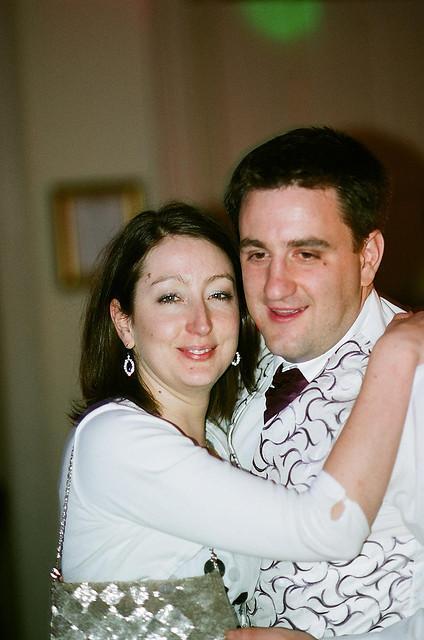How many people are there?
Give a very brief answer. 2. How many toilet covers are there?
Give a very brief answer. 0. 